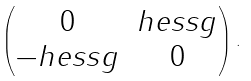<formula> <loc_0><loc_0><loc_500><loc_500>\begin{pmatrix} 0 & h e s s { g } \\ - h e s s { g } & 0 \end{pmatrix} .</formula> 